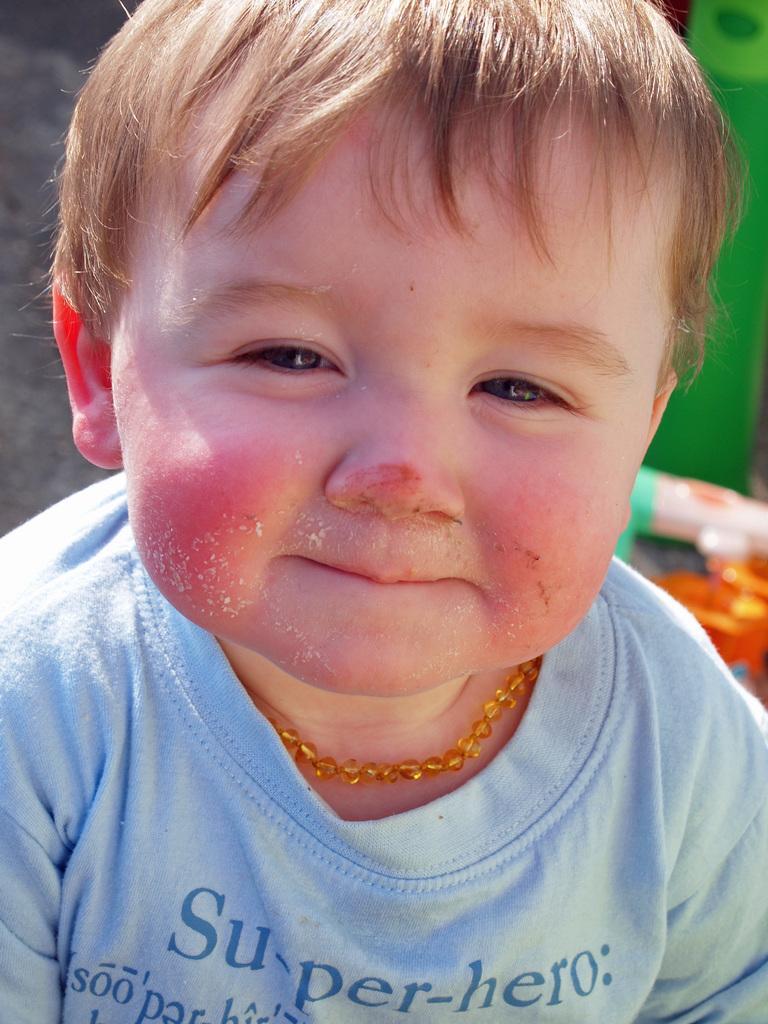Could you give a brief overview of what you see in this image? In the image there is a baby in blue t-shirt and gold hair with necklace to neck. 